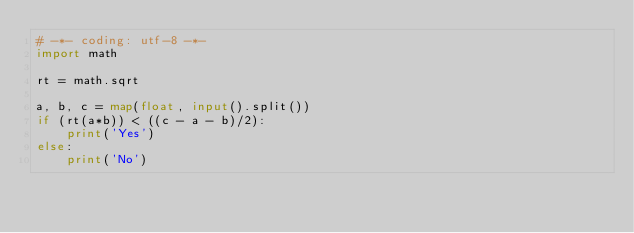Convert code to text. <code><loc_0><loc_0><loc_500><loc_500><_Python_># -*- coding: utf-8 -*-
import math

rt = math.sqrt

a, b, c = map(float, input().split())
if (rt(a*b)) < ((c - a - b)/2):
    print('Yes')
else:
    print('No')
</code> 